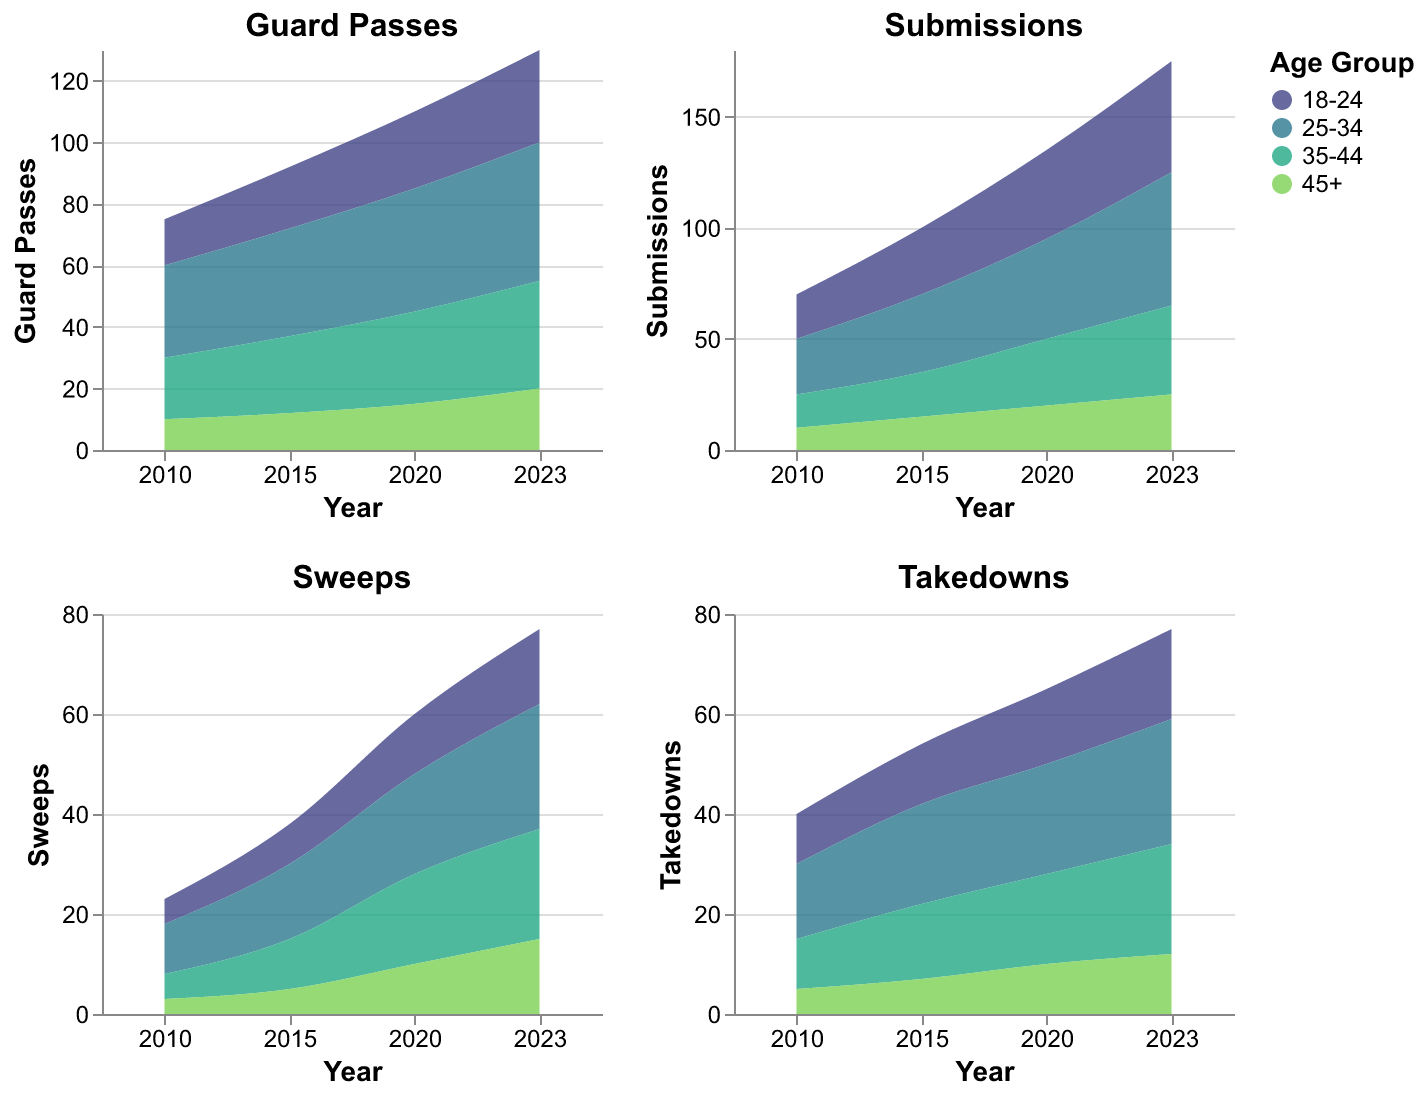How does the popularity of submissions change over the years for the 18-24 age group? The submission values for the 18-24 age group are: 2010 - 20, 2015 - 30, 2020 - 40, and 2023 - 50. By comparing these values over the years, we see a consistent increase.
Answer: Consistently increases Which age group had the highest number of takedowns in 2020? Referring to the Takedowns subplot for the year 2020, the values are: 18-24 - 15, 25-34 - 22, 35-44 - 18, and 45+ - 10. The 25-34 age group has the highest value.
Answer: 25-34 Compare the number of guard passes in 2015 and 2023 for the 35-44 age group. What is the difference? For the 35-44 age group, the values are: 2015 - 25, 2023 - 35, giving a difference of 35 - 25 = 10.
Answer: 10 Which technique showed the most significant increase in popularity for the 45+ age group from 2010 to 2023? Comparing all techniques for the 45+ age group over the years:
- Guard Passes: 2010 - 10, 2023 - 20 (Increase: 10)
- Submissions: 2010 - 10, 2023 - 25 (Increase: 15) 
- Sweeps: 2010 - 3, 2023 - 15 (Increase: 12)
- Takedowns: 2010 - 5, 2023 - 12 (Increase: 7)
Submissions show the highest increase (15).
Answer: Submissions What are the trends in the sweeps technique for the age group 25-34 from 2010 to 2023? The sweeps values for the 25-34 age group are: 2010 - 10, 2015 - 15, 2020 - 20, 2023 - 25, indicating a steady increase over the years.
Answer: Steady increase In which year did the 35-44 age group have the highest number of reversals, and what was that number? The reversal values for the 35-44 age group are as follows: 2010 - 3, 2015 - 4, 2020 - 6, 2023 - 8. The highest value is 8 in the year 2023.
Answer: 2023, 8 What is the cumulative total of guard passes for the 18-24 age group across all the years? Summing the guard passes for the 18-24 age group: 2010 (15) + 2015 (20) + 2020 (25) + 2023 (30) gives a total of 15 + 20 + 25 + 30 = 90.
Answer: 90 Compare the trend of takedowns and sweeps for the 25-34 age group from 2010 to 2023. Takedowns: 2010 (15), 2015 (20), 2020 (22), 2023 (25).
Sweeps: 2010 (10), 2015 (15), 2020 (20), 2023 (25).
Both techniques show a consistent increasing trend over the years.
Answer: Increasing trend for both Which age group had the lowest number of submissions in the year 2015? Referring to the Submissions subplot for the year 2015, the values are: 18-24 - 30, 25-34 - 35, 35-44 - 20, and 45+ - 15. The 45+ age group has the lowest number.
Answer: 45+ What is the average number of submissions for the 25-34 age group across all the years? The submission values for the 25-34 age group are: 25 (2010), 35 (2015), 45 (2020), and 60 (2023). Their total is 25 + 35 + 45 + 60 = 165. Dividing by 4, the average is 165 / 4 = 41.25.
Answer: 41.25 